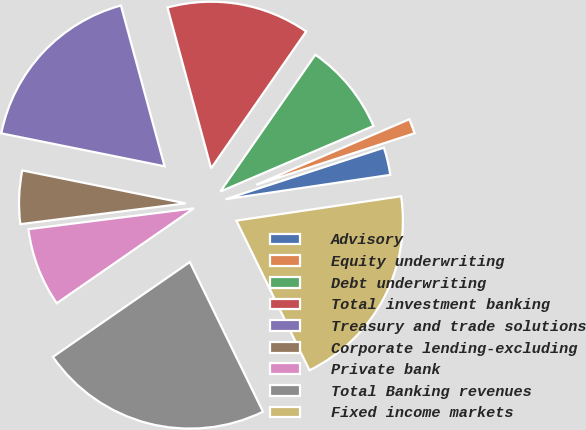Convert chart. <chart><loc_0><loc_0><loc_500><loc_500><pie_chart><fcel>Advisory<fcel>Equity underwriting<fcel>Debt underwriting<fcel>Total investment banking<fcel>Treasury and trade solutions<fcel>Corporate lending-excluding<fcel>Private bank<fcel>Total Banking revenues<fcel>Fixed income markets<nl><fcel>2.67%<fcel>1.43%<fcel>8.9%<fcel>13.88%<fcel>17.61%<fcel>5.16%<fcel>7.65%<fcel>22.59%<fcel>20.1%<nl></chart> 